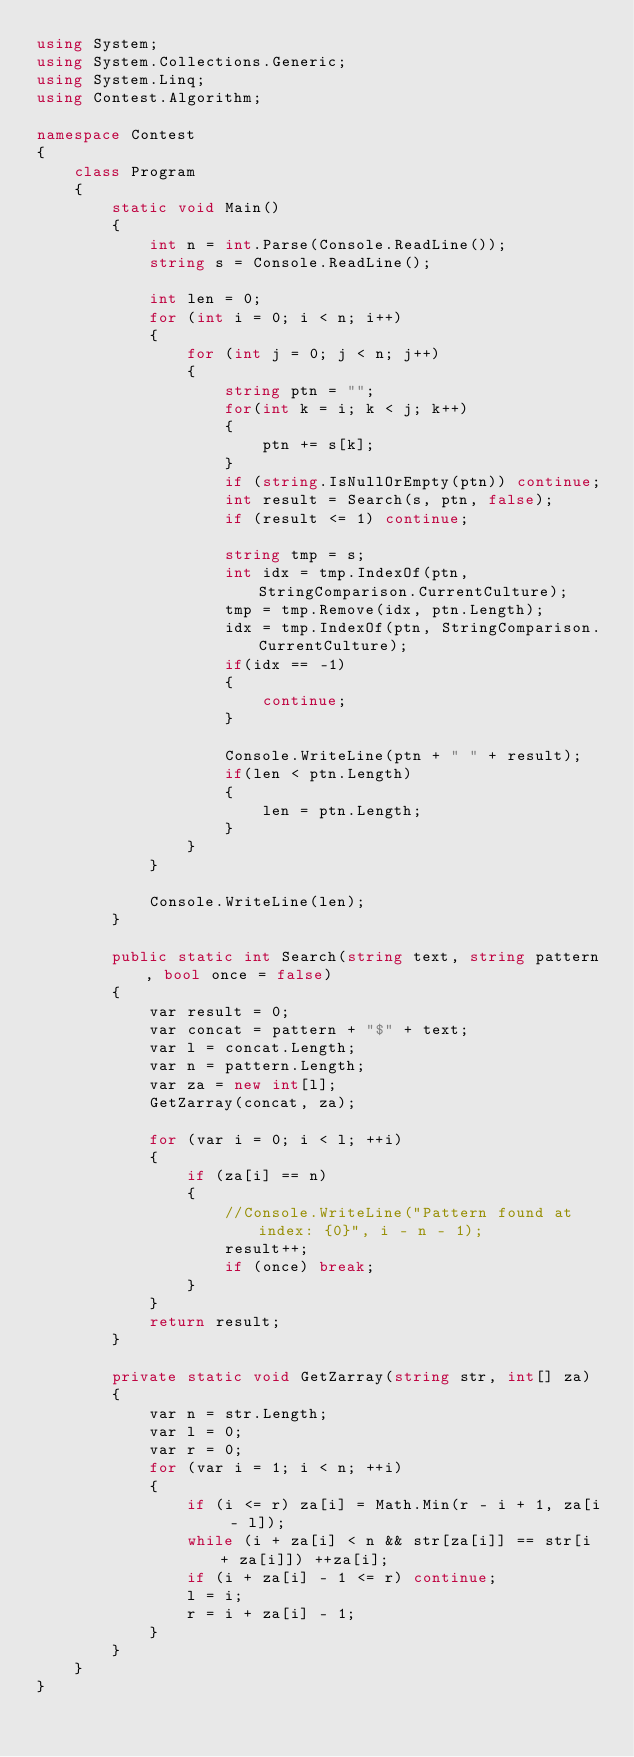<code> <loc_0><loc_0><loc_500><loc_500><_C#_>using System;
using System.Collections.Generic;
using System.Linq;
using Contest.Algorithm;

namespace Contest
{
    class Program
    {
        static void Main()
        {
            int n = int.Parse(Console.ReadLine());
            string s = Console.ReadLine();

            int len = 0;
            for (int i = 0; i < n; i++)
            {
                for (int j = 0; j < n; j++)
                {
                    string ptn = "";
                    for(int k = i; k < j; k++)
                    {
                        ptn += s[k];
                    }
                    if (string.IsNullOrEmpty(ptn)) continue;
                    int result = Search(s, ptn, false);
                    if (result <= 1) continue;

                    string tmp = s;
                    int idx = tmp.IndexOf(ptn, StringComparison.CurrentCulture);
                    tmp = tmp.Remove(idx, ptn.Length);
                    idx = tmp.IndexOf(ptn, StringComparison.CurrentCulture);
                    if(idx == -1)
                    {
                        continue;
                    }

                    Console.WriteLine(ptn + " " + result);
                    if(len < ptn.Length)
                    {
                        len = ptn.Length;
                    }
                }
            }
            
            Console.WriteLine(len);
        }

        public static int Search(string text, string pattern, bool once = false)
        {
            var result = 0;
            var concat = pattern + "$" + text;
            var l = concat.Length;
            var n = pattern.Length;
            var za = new int[l];
            GetZarray(concat, za);

            for (var i = 0; i < l; ++i)
            {
                if (za[i] == n)
                {
                    //Console.WriteLine("Pattern found at index: {0}", i - n - 1);
                    result++;
                    if (once) break;
                }
            }
            return result;
        }

        private static void GetZarray(string str, int[] za)
        {
            var n = str.Length;
            var l = 0;
            var r = 0;
            for (var i = 1; i < n; ++i)
            {
                if (i <= r) za[i] = Math.Min(r - i + 1, za[i - l]);
                while (i + za[i] < n && str[za[i]] == str[i + za[i]]) ++za[i];
                if (i + za[i] - 1 <= r) continue;
                l = i;
                r = i + za[i] - 1;
            }
        }
    }
}
</code> 